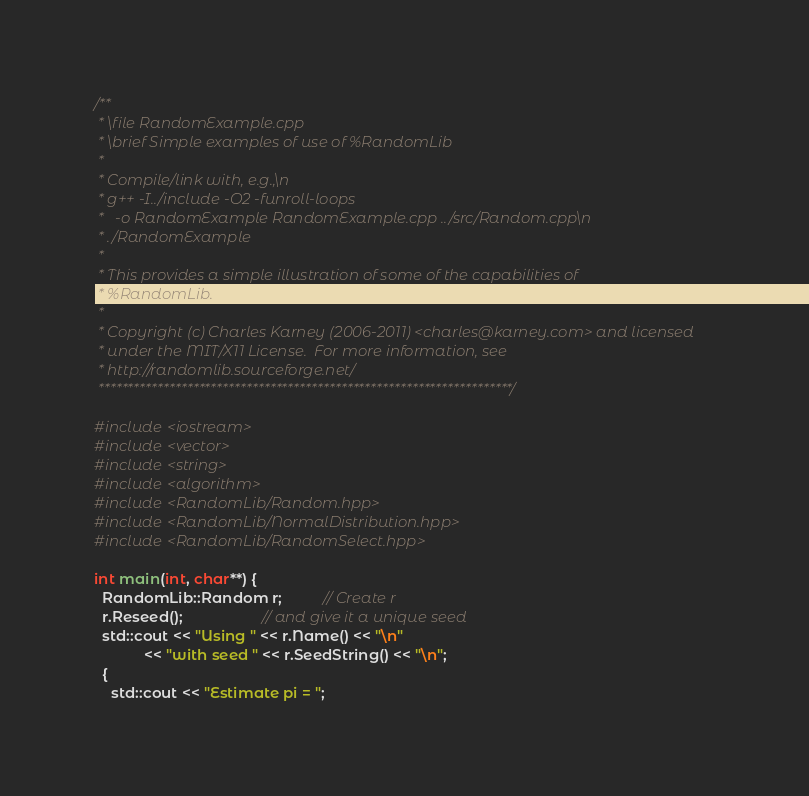Convert code to text. <code><loc_0><loc_0><loc_500><loc_500><_C++_>/**
 * \file RandomExample.cpp
 * \brief Simple examples of use of %RandomLib
 *
 * Compile/link with, e.g.,\n
 * g++ -I../include -O2 -funroll-loops
 *   -o RandomExample RandomExample.cpp ../src/Random.cpp\n
 * ./RandomExample
 *
 * This provides a simple illustration of some of the capabilities of
 * %RandomLib.
 *
 * Copyright (c) Charles Karney (2006-2011) <charles@karney.com> and licensed
 * under the MIT/X11 License.  For more information, see
 * http://randomlib.sourceforge.net/
 **********************************************************************/

#include <iostream>
#include <vector>
#include <string>
#include <algorithm>
#include <RandomLib/Random.hpp>
#include <RandomLib/NormalDistribution.hpp>
#include <RandomLib/RandomSelect.hpp>

int main(int, char**) {
  RandomLib::Random r;          // Create r
  r.Reseed();                   // and give it a unique seed
  std::cout << "Using " << r.Name() << "\n"
            << "with seed " << r.SeedString() << "\n";
  {
    std::cout << "Estimate pi = ";</code> 